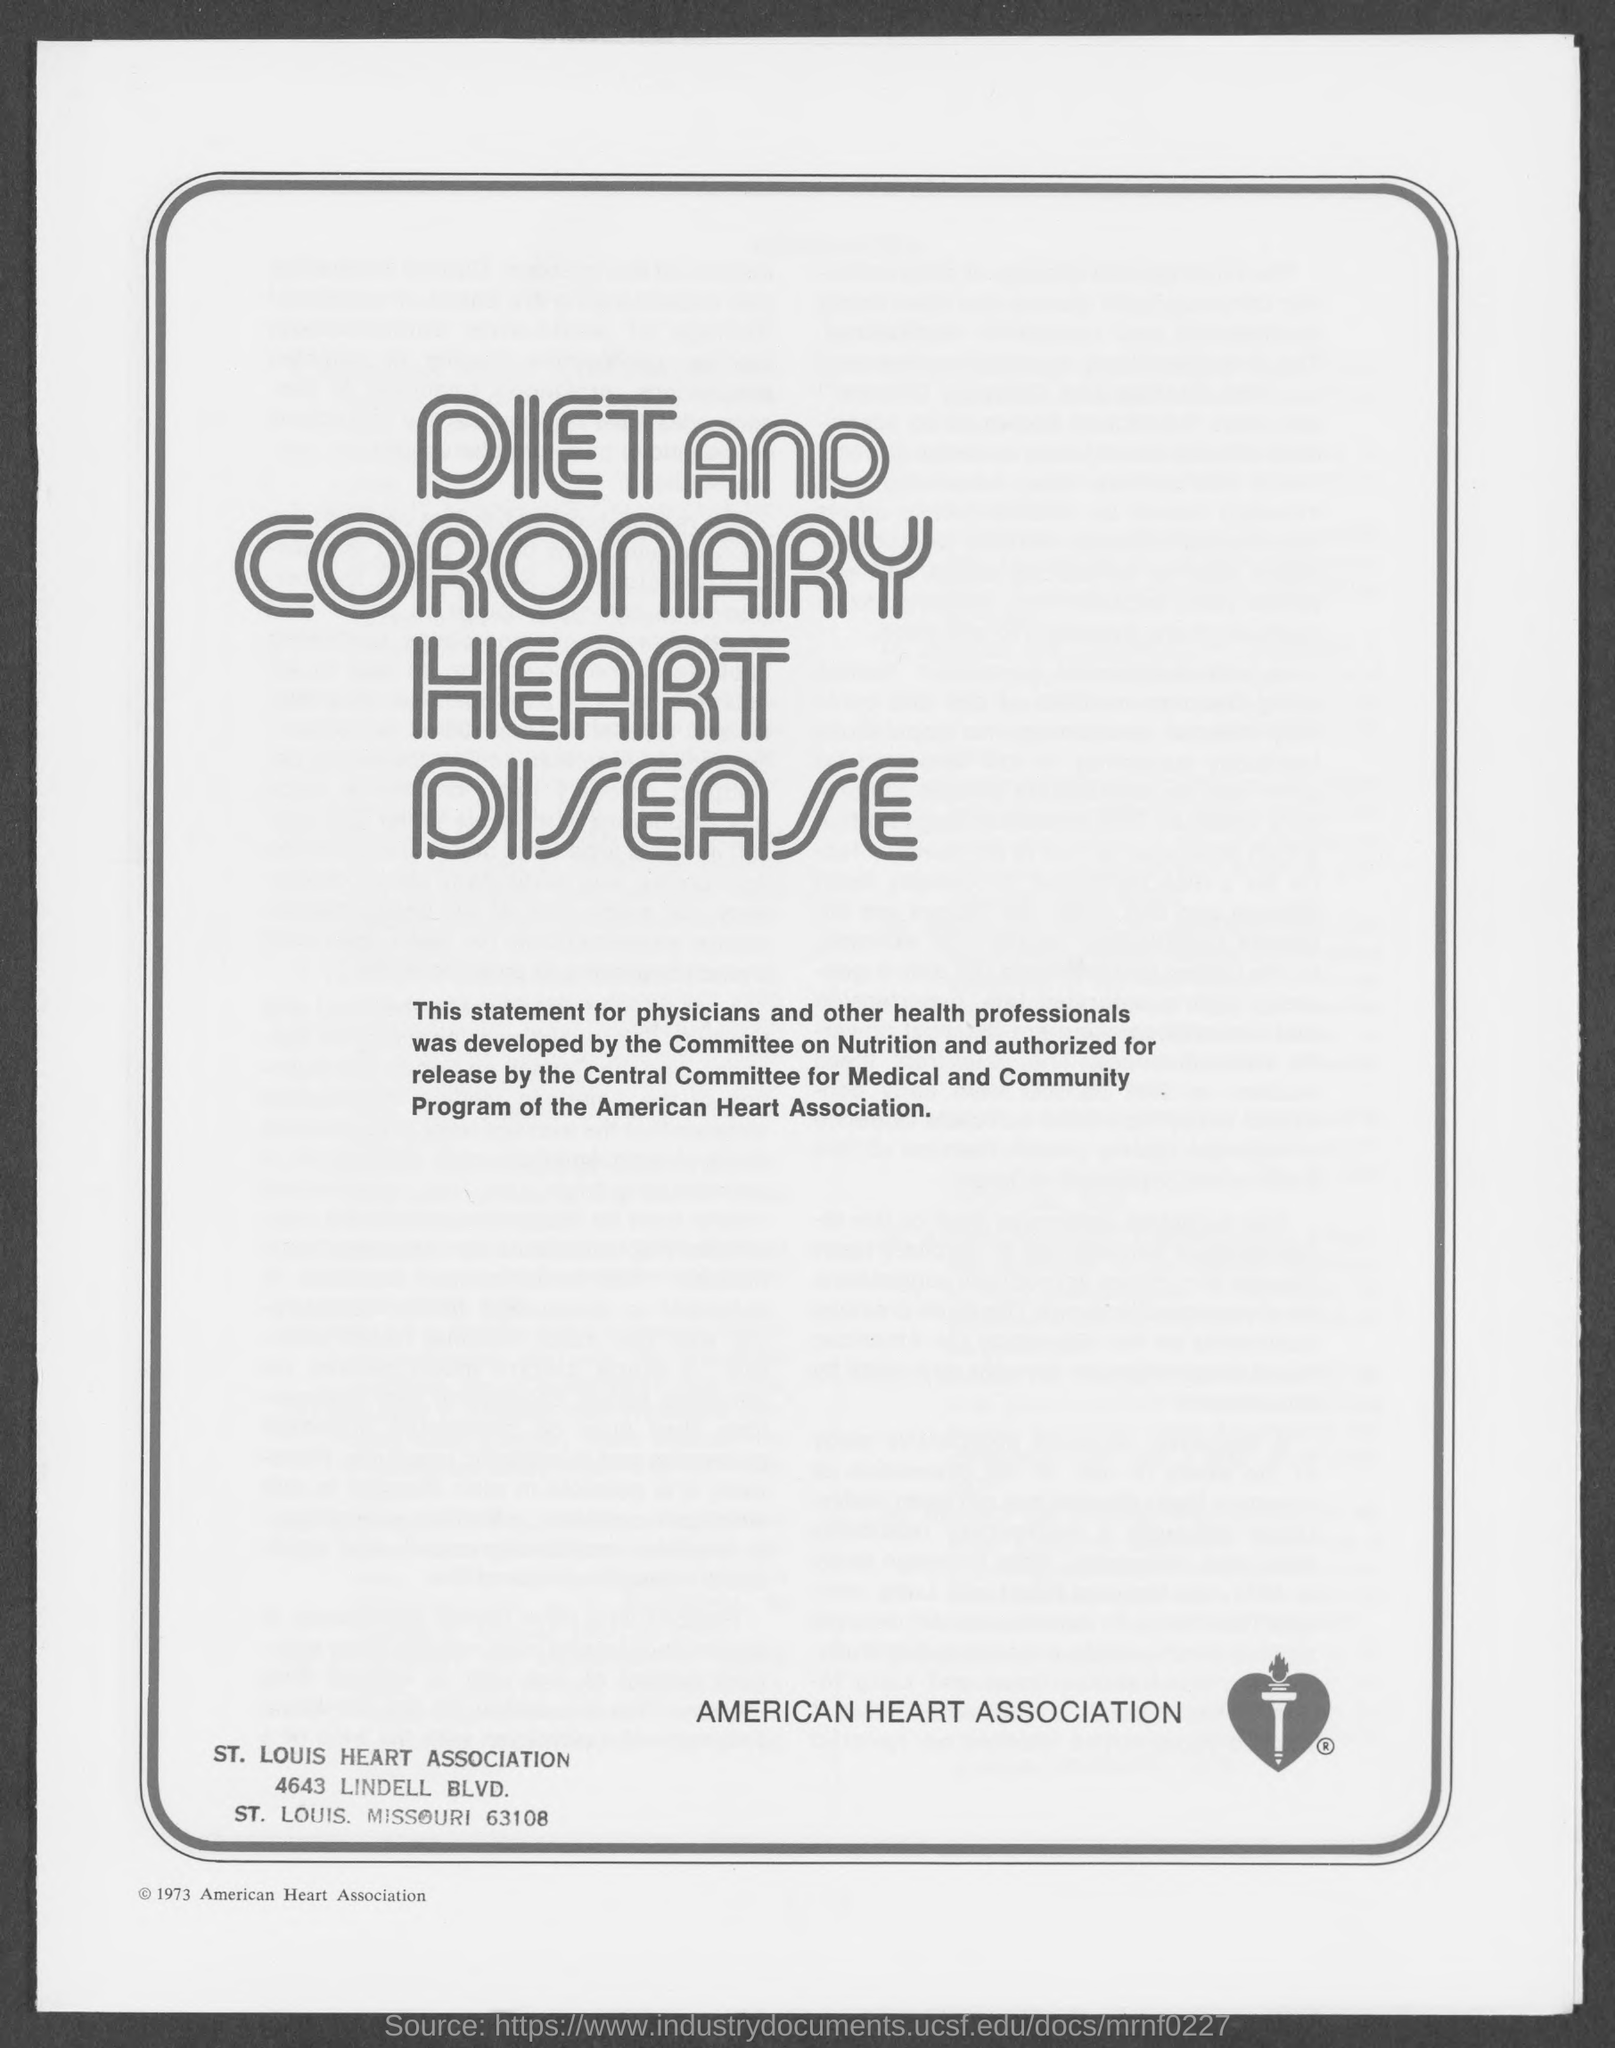What is the name of heart association ?
Offer a very short reply. American Heart Association. What is the street address of st. louis heart association ?
Ensure brevity in your answer.  4643 Lindell Blvd. 